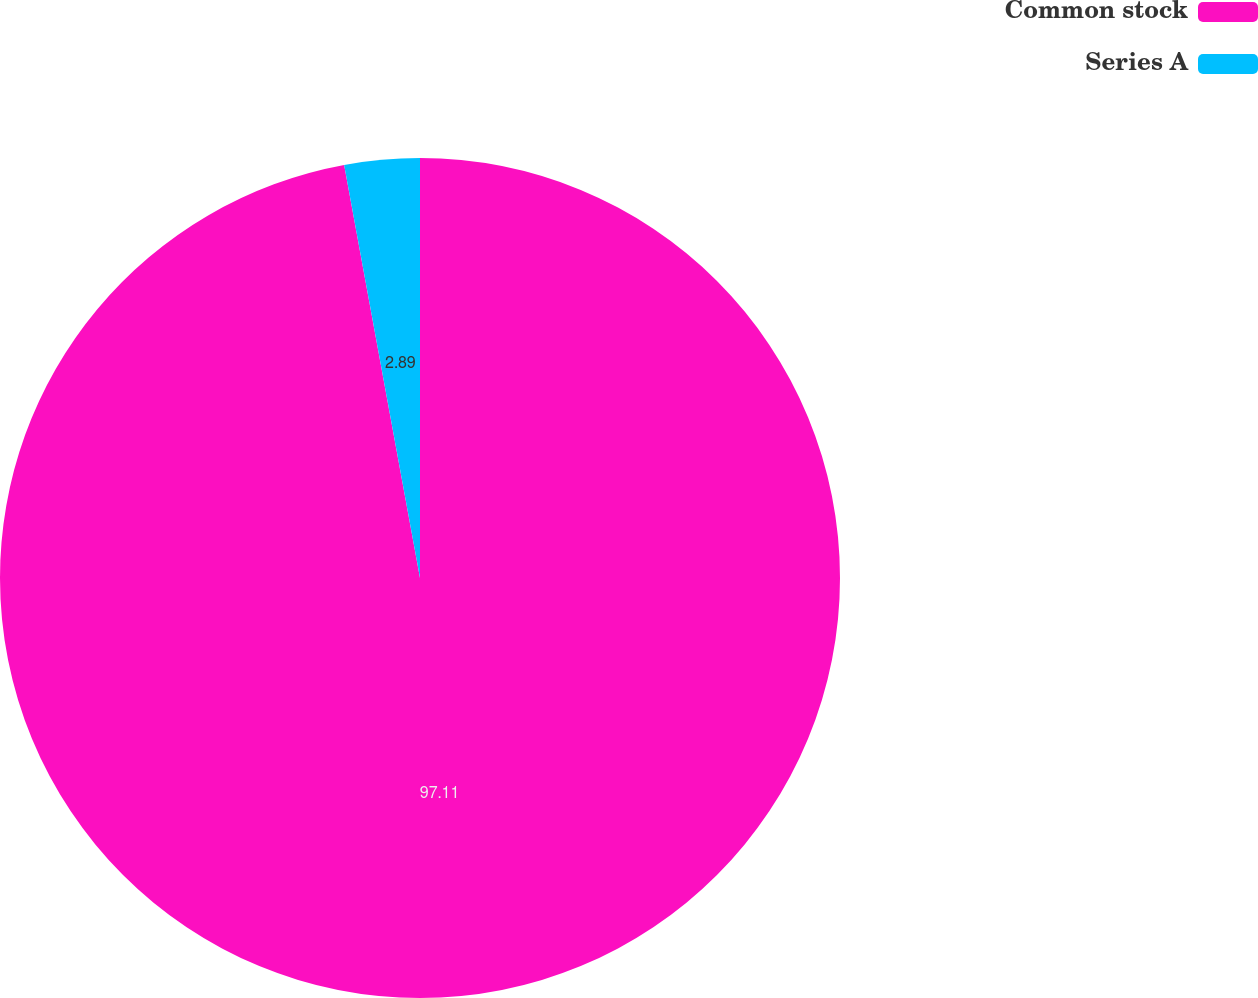Convert chart. <chart><loc_0><loc_0><loc_500><loc_500><pie_chart><fcel>Common stock<fcel>Series A<nl><fcel>97.11%<fcel>2.89%<nl></chart> 